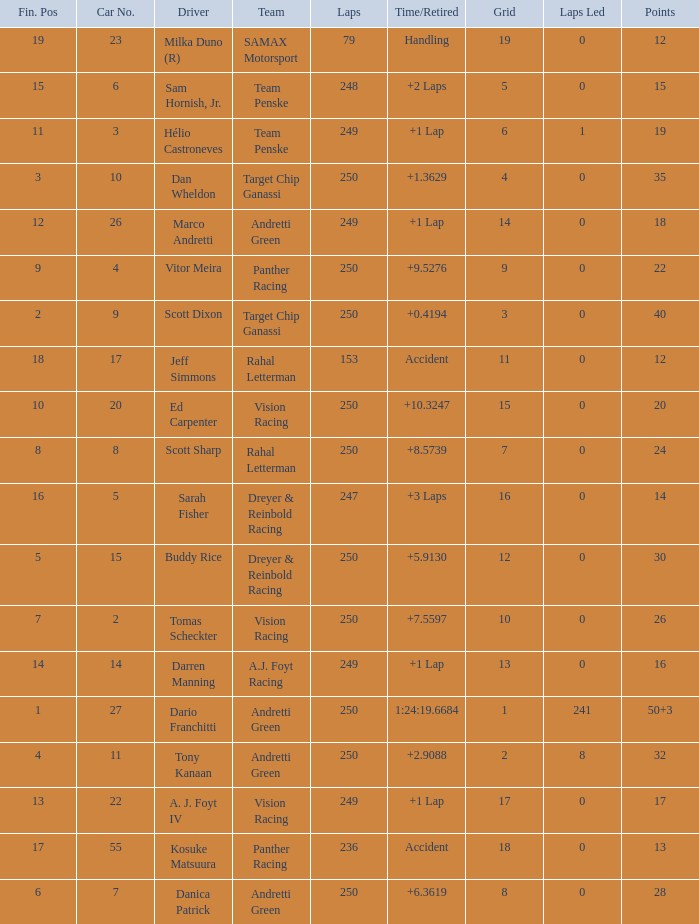Name the total number of cars for panther racing and grid of 9 1.0. 